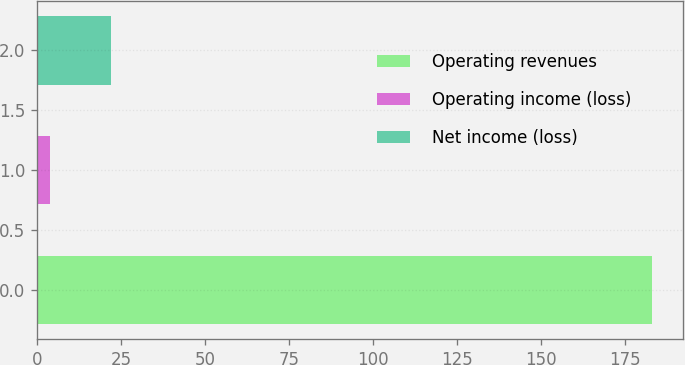Convert chart to OTSL. <chart><loc_0><loc_0><loc_500><loc_500><bar_chart><fcel>Operating revenues<fcel>Operating income (loss)<fcel>Net income (loss)<nl><fcel>183<fcel>4<fcel>21.9<nl></chart> 